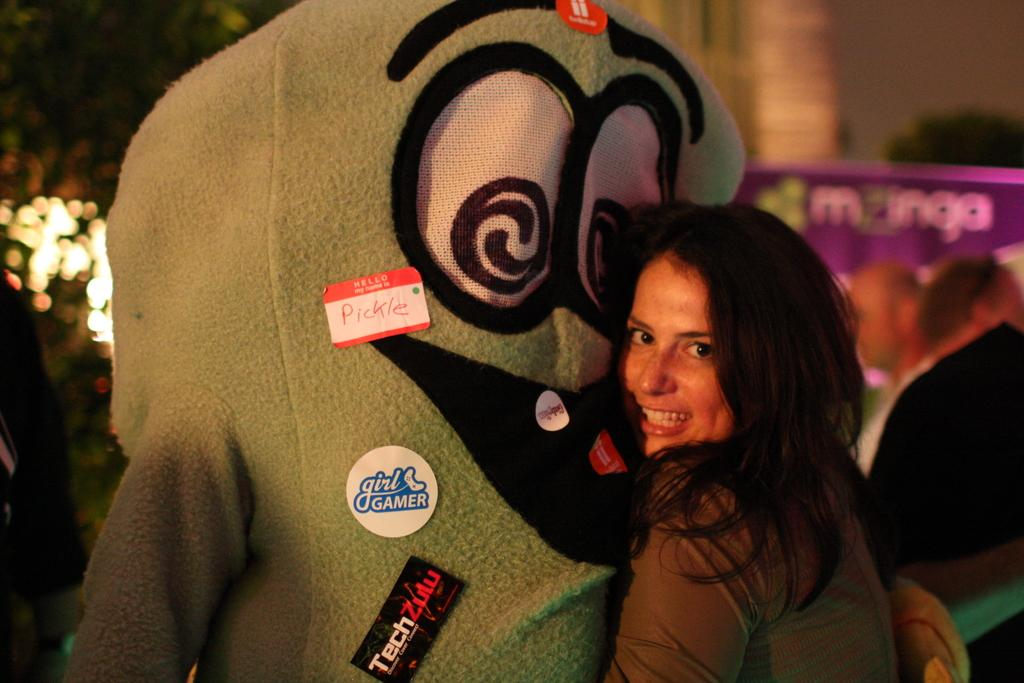Who is the main subject in the image? There is a girl in the image. What is the girl doing in the image? The girl is smiling in the image. What is the girl holding or interacting with in the image? The girl is hugged by a teddy bear in the image. What can be seen in the background of the image? There are trees and a building in the background of the image. What type of twist can be seen in the image? There is no twist present in the image. 